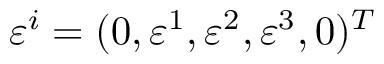<formula> <loc_0><loc_0><loc_500><loc_500>\varepsilon ^ { i } = ( 0 , \varepsilon ^ { 1 } , \varepsilon ^ { 2 } , \varepsilon ^ { 3 } , 0 ) ^ { T }</formula> 